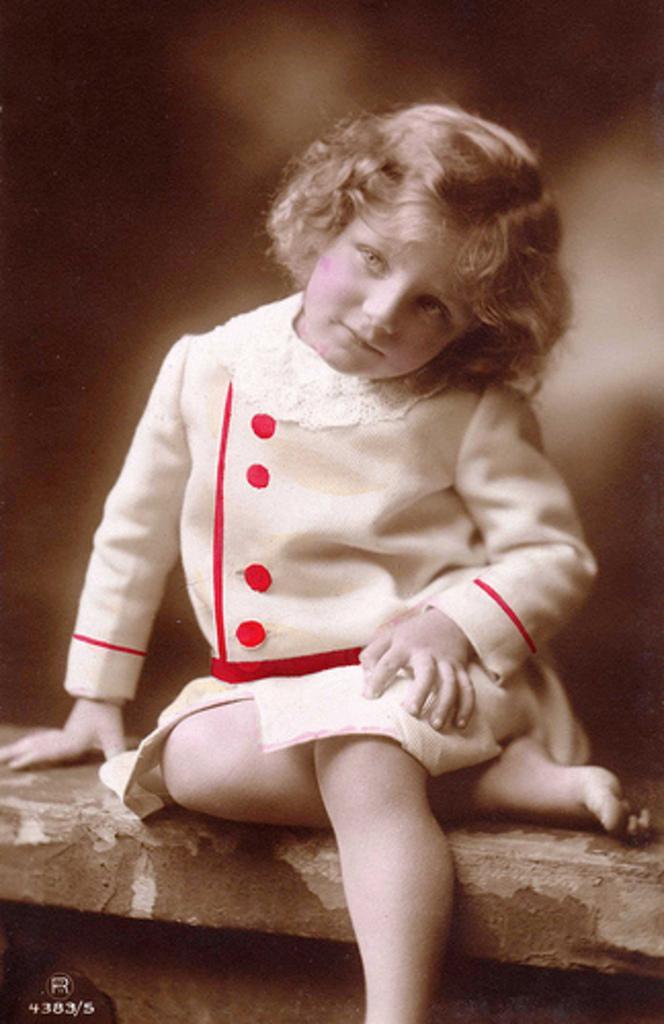Describe this image in one or two sentences. In this image I can see the person sitting and the person is wearing red and white color dress and I can see the blurred background. 